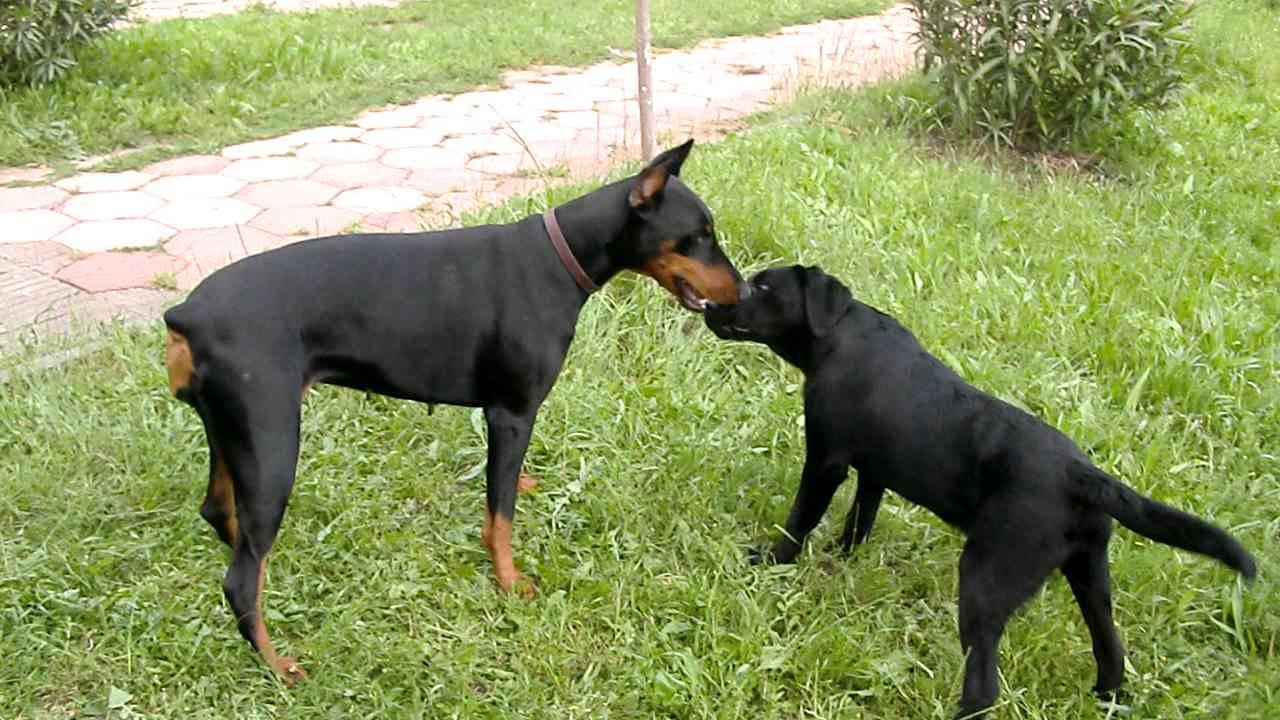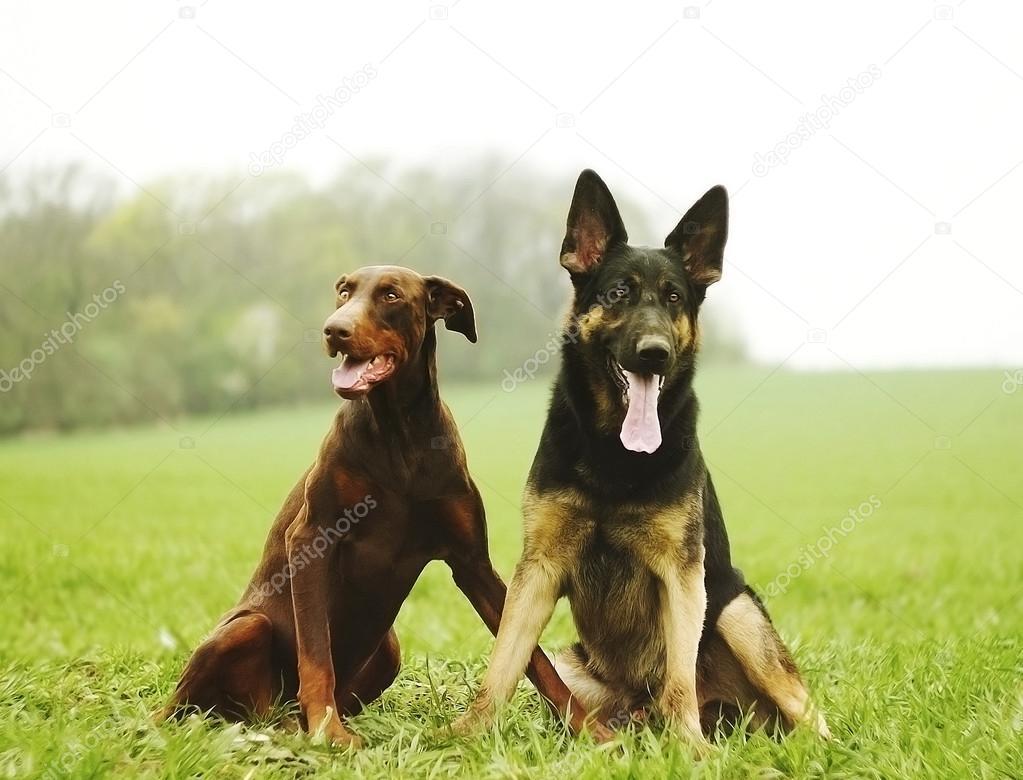The first image is the image on the left, the second image is the image on the right. Considering the images on both sides, is "At least three dogs are dobermans with upright pointy ears, and no dogs are standing up with all four paws on the ground." valid? Answer yes or no. No. The first image is the image on the left, the second image is the image on the right. Considering the images on both sides, is "Two dogs are standing in the grass in the image on the left." valid? Answer yes or no. Yes. 